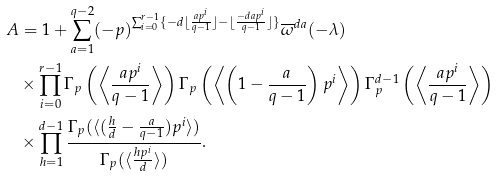<formula> <loc_0><loc_0><loc_500><loc_500>A & = 1 + \sum _ { a = 1 } ^ { q - 2 } ( - p ) ^ { \sum _ { i = 0 } ^ { r - 1 } \{ - d \lfloor \frac { a p ^ { i } } { q - 1 } \rfloor - \lfloor \frac { - d a p ^ { i } } { q - 1 } \rfloor \} } \overline { \omega } ^ { d a } ( - \lambda ) \\ & \times \prod _ { i = 0 } ^ { r - 1 } \Gamma _ { p } \left ( \left \langle \frac { a p ^ { i } } { q - 1 } \right \rangle \right ) \Gamma _ { p } \left ( \left \langle \left ( 1 - \frac { a } { q - 1 } \right ) p ^ { i } \right \rangle \right ) \Gamma _ { p } ^ { d - 1 } \left ( \left \langle \frac { a p ^ { i } } { q - 1 } \right \rangle \right ) \\ & \times \prod _ { h = 1 } ^ { d - 1 } \frac { \Gamma _ { p } ( \langle ( \frac { h } { d } - \frac { a } { q - 1 } ) p ^ { i } \rangle ) } { \Gamma _ { p } ( \langle \frac { h p ^ { i } } { d } \rangle ) } .</formula> 